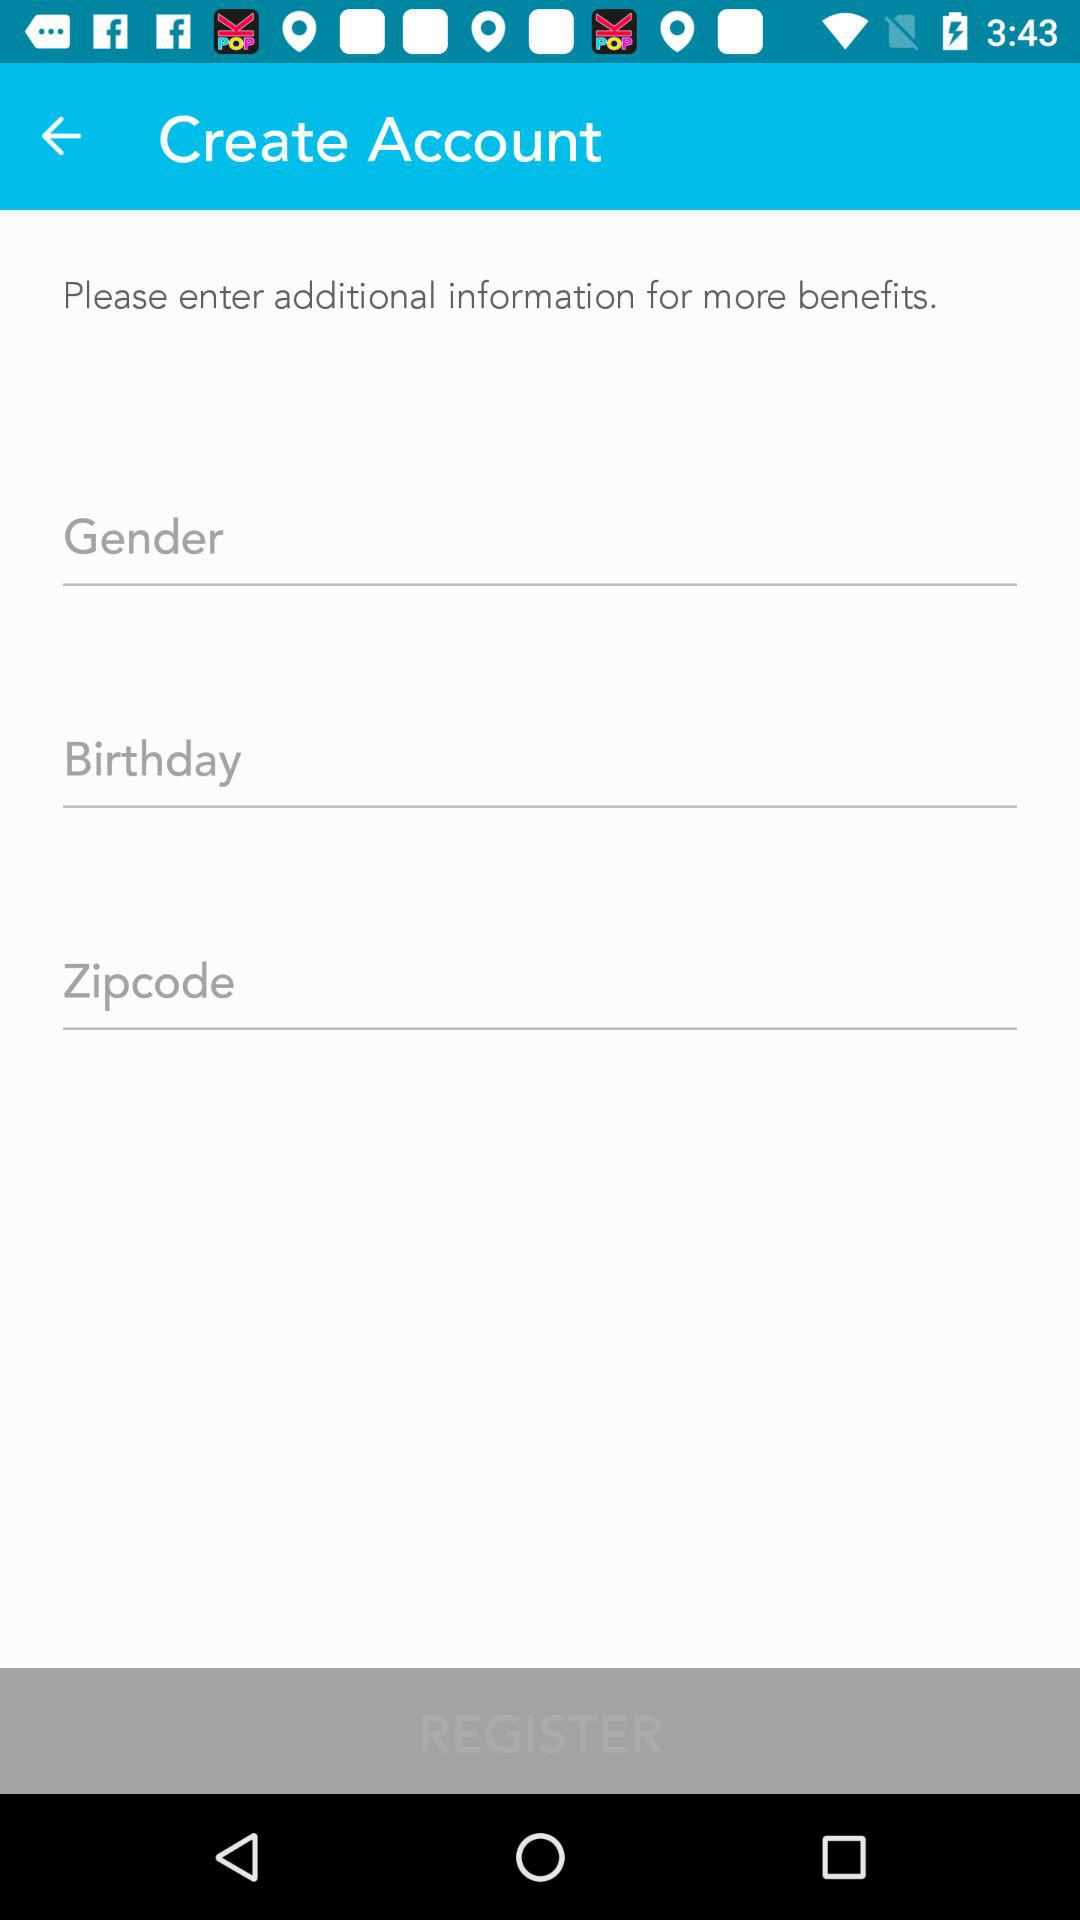How many text inputs are required to register an account?
Answer the question using a single word or phrase. 3 